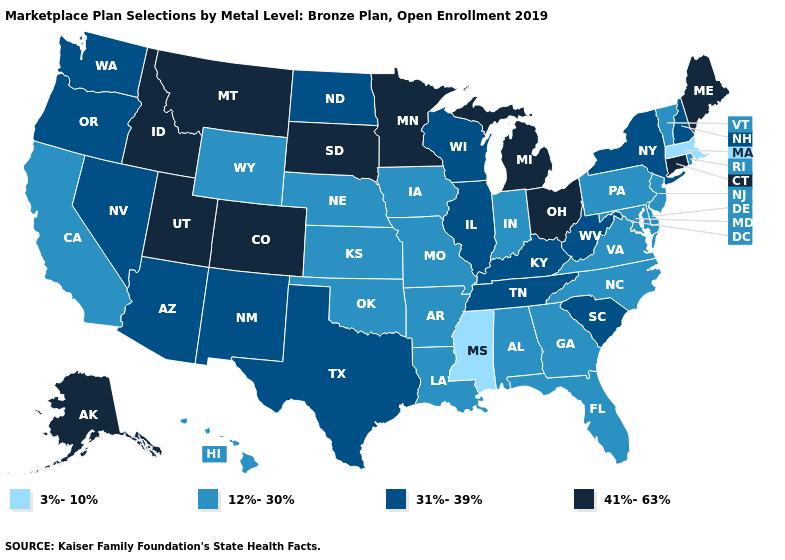Name the states that have a value in the range 41%-63%?
Short answer required. Alaska, Colorado, Connecticut, Idaho, Maine, Michigan, Minnesota, Montana, Ohio, South Dakota, Utah. What is the value of Florida?
Answer briefly. 12%-30%. Name the states that have a value in the range 3%-10%?
Short answer required. Massachusetts, Mississippi. What is the value of Wisconsin?
Concise answer only. 31%-39%. Does the first symbol in the legend represent the smallest category?
Give a very brief answer. Yes. Is the legend a continuous bar?
Write a very short answer. No. Which states have the lowest value in the MidWest?
Answer briefly. Indiana, Iowa, Kansas, Missouri, Nebraska. Name the states that have a value in the range 3%-10%?
Be succinct. Massachusetts, Mississippi. What is the value of Oklahoma?
Answer briefly. 12%-30%. Does Minnesota have the lowest value in the USA?
Concise answer only. No. Does the map have missing data?
Write a very short answer. No. Which states hav the highest value in the MidWest?
Concise answer only. Michigan, Minnesota, Ohio, South Dakota. What is the value of Colorado?
Answer briefly. 41%-63%. Does Nebraska have a higher value than California?
Be succinct. No. Is the legend a continuous bar?
Answer briefly. No. 